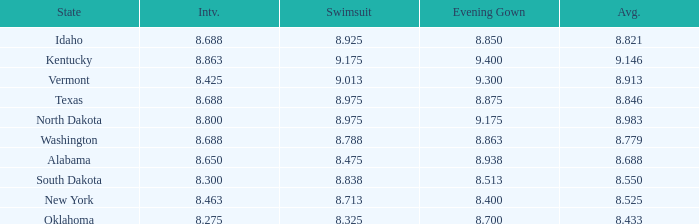Who had the lowest interview score from South Dakota with an evening gown less than 8.513? None. 